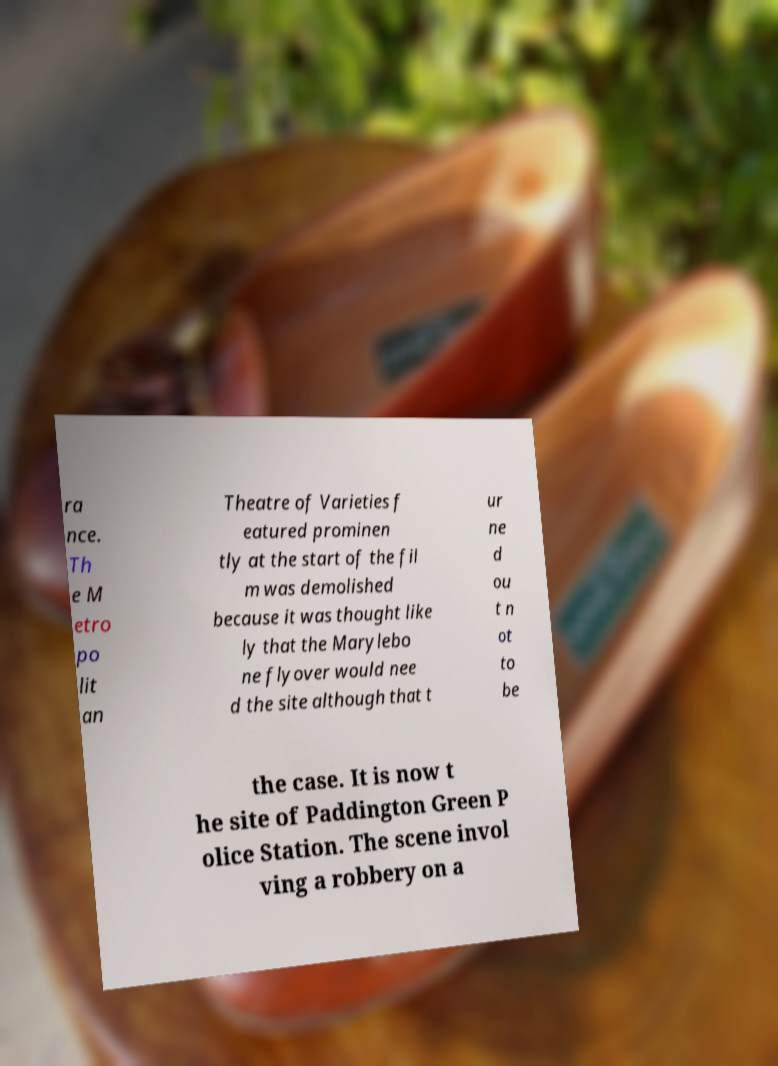Could you extract and type out the text from this image? ra nce. Th e M etro po lit an Theatre of Varieties f eatured prominen tly at the start of the fil m was demolished because it was thought like ly that the Marylebo ne flyover would nee d the site although that t ur ne d ou t n ot to be the case. It is now t he site of Paddington Green P olice Station. The scene invol ving a robbery on a 